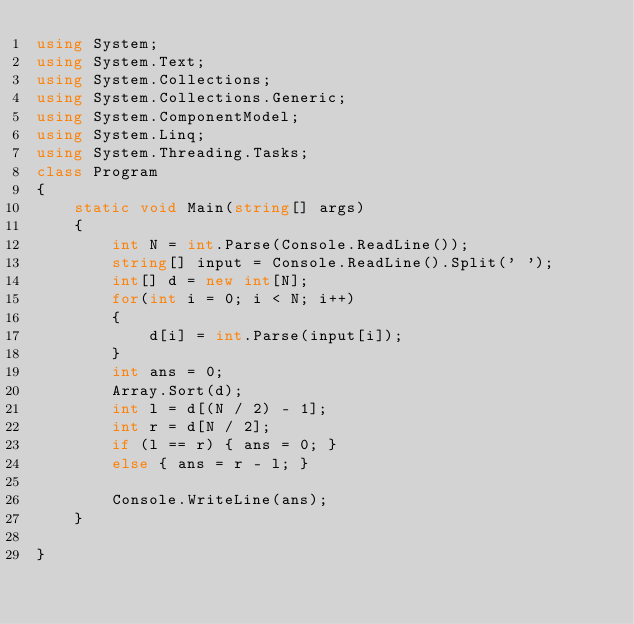<code> <loc_0><loc_0><loc_500><loc_500><_C#_>using System;
using System.Text;
using System.Collections;
using System.Collections.Generic;
using System.ComponentModel;
using System.Linq;
using System.Threading.Tasks;
class Program
{
	static void Main(string[] args)
	{
		int N = int.Parse(Console.ReadLine());
		string[] input = Console.ReadLine().Split(' ');
		int[] d = new int[N];
        for(int i = 0; i < N; i++)
		{
			d[i] = int.Parse(input[i]);
		}
		int ans = 0;
		Array.Sort(d);
		int l = d[(N / 2) - 1];
		int r = d[N / 2];
		if (l == r) { ans = 0; }
		else { ans = r - l; }

		Console.WriteLine(ans);
	}
	
}</code> 